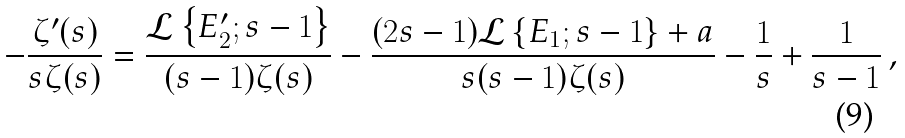Convert formula to latex. <formula><loc_0><loc_0><loc_500><loc_500>- \frac { \zeta ^ { \prime } ( s ) } { s \zeta ( s ) } = \frac { \mathcal { L } \left \{ E ^ { \prime } _ { 2 } ; s - 1 \right \} } { ( s - 1 ) \zeta ( s ) } - \frac { ( 2 s - 1 ) \mathcal { L } \left \{ E _ { 1 } ; s - 1 \right \} + a } { s ( s - 1 ) \zeta ( s ) } - \frac { 1 } { s } + \frac { 1 } { s - 1 } \, ,</formula> 